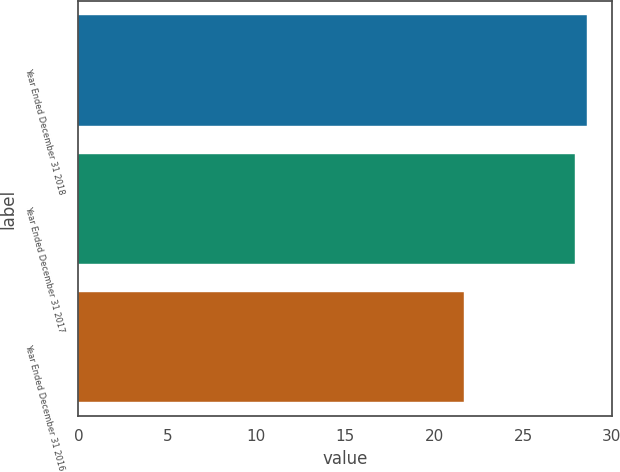Convert chart. <chart><loc_0><loc_0><loc_500><loc_500><bar_chart><fcel>Year Ended December 31 2018<fcel>Year Ended December 31 2017<fcel>Year Ended December 31 2016<nl><fcel>28.58<fcel>27.9<fcel>21.7<nl></chart> 